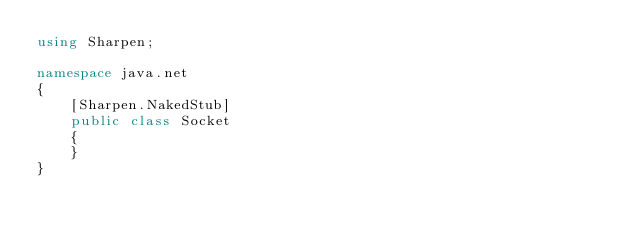Convert code to text. <code><loc_0><loc_0><loc_500><loc_500><_C#_>using Sharpen;

namespace java.net
{
	[Sharpen.NakedStub]
	public class Socket
	{
	}
}
</code> 